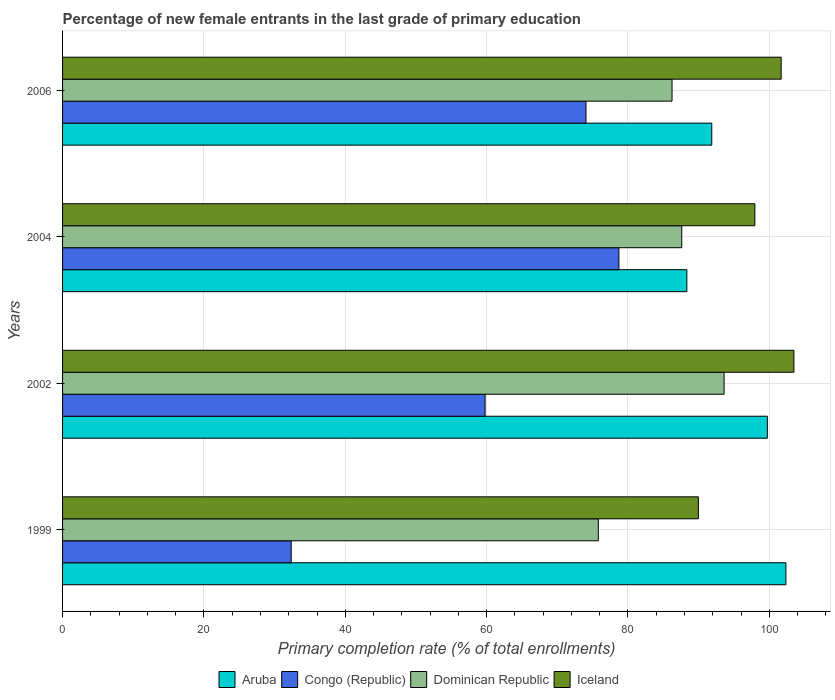Are the number of bars per tick equal to the number of legend labels?
Ensure brevity in your answer.  Yes. Are the number of bars on each tick of the Y-axis equal?
Ensure brevity in your answer.  Yes. How many bars are there on the 4th tick from the bottom?
Provide a succinct answer. 4. What is the label of the 3rd group of bars from the top?
Make the answer very short. 2002. What is the percentage of new female entrants in Congo (Republic) in 1999?
Ensure brevity in your answer.  32.35. Across all years, what is the maximum percentage of new female entrants in Dominican Republic?
Your answer should be very brief. 93.6. Across all years, what is the minimum percentage of new female entrants in Congo (Republic)?
Provide a short and direct response. 32.35. In which year was the percentage of new female entrants in Congo (Republic) maximum?
Offer a terse response. 2004. What is the total percentage of new female entrants in Aruba in the graph?
Give a very brief answer. 382.24. What is the difference between the percentage of new female entrants in Dominican Republic in 1999 and that in 2006?
Make the answer very short. -10.43. What is the difference between the percentage of new female entrants in Congo (Republic) in 2006 and the percentage of new female entrants in Iceland in 2002?
Offer a terse response. -29.42. What is the average percentage of new female entrants in Dominican Republic per year?
Provide a short and direct response. 85.81. In the year 2002, what is the difference between the percentage of new female entrants in Iceland and percentage of new female entrants in Congo (Republic)?
Keep it short and to the point. 43.7. What is the ratio of the percentage of new female entrants in Aruba in 2004 to that in 2006?
Give a very brief answer. 0.96. Is the percentage of new female entrants in Congo (Republic) in 2004 less than that in 2006?
Your answer should be very brief. No. What is the difference between the highest and the second highest percentage of new female entrants in Iceland?
Give a very brief answer. 1.8. What is the difference between the highest and the lowest percentage of new female entrants in Iceland?
Your response must be concise. 13.52. Is it the case that in every year, the sum of the percentage of new female entrants in Aruba and percentage of new female entrants in Congo (Republic) is greater than the sum of percentage of new female entrants in Dominican Republic and percentage of new female entrants in Iceland?
Your answer should be compact. No. What does the 1st bar from the bottom in 2004 represents?
Your answer should be compact. Aruba. Is it the case that in every year, the sum of the percentage of new female entrants in Congo (Republic) and percentage of new female entrants in Iceland is greater than the percentage of new female entrants in Dominican Republic?
Offer a terse response. Yes. How many years are there in the graph?
Your answer should be compact. 4. What is the difference between two consecutive major ticks on the X-axis?
Keep it short and to the point. 20. What is the title of the graph?
Provide a succinct answer. Percentage of new female entrants in the last grade of primary education. What is the label or title of the X-axis?
Provide a succinct answer. Primary completion rate (% of total enrollments). What is the label or title of the Y-axis?
Provide a succinct answer. Years. What is the Primary completion rate (% of total enrollments) in Aruba in 1999?
Offer a terse response. 102.34. What is the Primary completion rate (% of total enrollments) in Congo (Republic) in 1999?
Give a very brief answer. 32.35. What is the Primary completion rate (% of total enrollments) in Dominican Republic in 1999?
Provide a succinct answer. 75.8. What is the Primary completion rate (% of total enrollments) of Iceland in 1999?
Your answer should be very brief. 89.96. What is the Primary completion rate (% of total enrollments) in Aruba in 2002?
Make the answer very short. 99.72. What is the Primary completion rate (% of total enrollments) in Congo (Republic) in 2002?
Your answer should be compact. 59.78. What is the Primary completion rate (% of total enrollments) in Dominican Republic in 2002?
Provide a short and direct response. 93.6. What is the Primary completion rate (% of total enrollments) in Iceland in 2002?
Provide a short and direct response. 103.48. What is the Primary completion rate (% of total enrollments) of Aruba in 2004?
Make the answer very short. 88.33. What is the Primary completion rate (% of total enrollments) in Congo (Republic) in 2004?
Give a very brief answer. 78.72. What is the Primary completion rate (% of total enrollments) in Dominican Republic in 2004?
Ensure brevity in your answer.  87.61. What is the Primary completion rate (% of total enrollments) of Iceland in 2004?
Give a very brief answer. 97.95. What is the Primary completion rate (% of total enrollments) of Aruba in 2006?
Your answer should be compact. 91.85. What is the Primary completion rate (% of total enrollments) in Congo (Republic) in 2006?
Keep it short and to the point. 74.06. What is the Primary completion rate (% of total enrollments) in Dominican Republic in 2006?
Your answer should be compact. 86.23. What is the Primary completion rate (% of total enrollments) of Iceland in 2006?
Ensure brevity in your answer.  101.67. Across all years, what is the maximum Primary completion rate (% of total enrollments) in Aruba?
Offer a very short reply. 102.34. Across all years, what is the maximum Primary completion rate (% of total enrollments) of Congo (Republic)?
Your answer should be very brief. 78.72. Across all years, what is the maximum Primary completion rate (% of total enrollments) in Dominican Republic?
Keep it short and to the point. 93.6. Across all years, what is the maximum Primary completion rate (% of total enrollments) in Iceland?
Ensure brevity in your answer.  103.48. Across all years, what is the minimum Primary completion rate (% of total enrollments) of Aruba?
Provide a succinct answer. 88.33. Across all years, what is the minimum Primary completion rate (% of total enrollments) in Congo (Republic)?
Keep it short and to the point. 32.35. Across all years, what is the minimum Primary completion rate (% of total enrollments) in Dominican Republic?
Provide a succinct answer. 75.8. Across all years, what is the minimum Primary completion rate (% of total enrollments) in Iceland?
Ensure brevity in your answer.  89.96. What is the total Primary completion rate (% of total enrollments) of Aruba in the graph?
Keep it short and to the point. 382.24. What is the total Primary completion rate (% of total enrollments) in Congo (Republic) in the graph?
Offer a very short reply. 244.9. What is the total Primary completion rate (% of total enrollments) in Dominican Republic in the graph?
Offer a very short reply. 343.24. What is the total Primary completion rate (% of total enrollments) of Iceland in the graph?
Offer a very short reply. 393.06. What is the difference between the Primary completion rate (% of total enrollments) of Aruba in 1999 and that in 2002?
Keep it short and to the point. 2.62. What is the difference between the Primary completion rate (% of total enrollments) in Congo (Republic) in 1999 and that in 2002?
Offer a very short reply. -27.43. What is the difference between the Primary completion rate (% of total enrollments) in Dominican Republic in 1999 and that in 2002?
Provide a succinct answer. -17.79. What is the difference between the Primary completion rate (% of total enrollments) of Iceland in 1999 and that in 2002?
Your answer should be very brief. -13.52. What is the difference between the Primary completion rate (% of total enrollments) of Aruba in 1999 and that in 2004?
Give a very brief answer. 14.01. What is the difference between the Primary completion rate (% of total enrollments) in Congo (Republic) in 1999 and that in 2004?
Give a very brief answer. -46.37. What is the difference between the Primary completion rate (% of total enrollments) of Dominican Republic in 1999 and that in 2004?
Offer a very short reply. -11.81. What is the difference between the Primary completion rate (% of total enrollments) in Iceland in 1999 and that in 2004?
Offer a terse response. -7.99. What is the difference between the Primary completion rate (% of total enrollments) in Aruba in 1999 and that in 2006?
Offer a terse response. 10.49. What is the difference between the Primary completion rate (% of total enrollments) in Congo (Republic) in 1999 and that in 2006?
Your answer should be very brief. -41.71. What is the difference between the Primary completion rate (% of total enrollments) of Dominican Republic in 1999 and that in 2006?
Ensure brevity in your answer.  -10.43. What is the difference between the Primary completion rate (% of total enrollments) of Iceland in 1999 and that in 2006?
Keep it short and to the point. -11.72. What is the difference between the Primary completion rate (% of total enrollments) in Aruba in 2002 and that in 2004?
Your answer should be compact. 11.39. What is the difference between the Primary completion rate (% of total enrollments) in Congo (Republic) in 2002 and that in 2004?
Your answer should be compact. -18.94. What is the difference between the Primary completion rate (% of total enrollments) of Dominican Republic in 2002 and that in 2004?
Offer a very short reply. 5.99. What is the difference between the Primary completion rate (% of total enrollments) in Iceland in 2002 and that in 2004?
Provide a succinct answer. 5.53. What is the difference between the Primary completion rate (% of total enrollments) of Aruba in 2002 and that in 2006?
Offer a very short reply. 7.87. What is the difference between the Primary completion rate (% of total enrollments) in Congo (Republic) in 2002 and that in 2006?
Keep it short and to the point. -14.28. What is the difference between the Primary completion rate (% of total enrollments) of Dominican Republic in 2002 and that in 2006?
Provide a succinct answer. 7.36. What is the difference between the Primary completion rate (% of total enrollments) of Iceland in 2002 and that in 2006?
Give a very brief answer. 1.8. What is the difference between the Primary completion rate (% of total enrollments) in Aruba in 2004 and that in 2006?
Your answer should be very brief. -3.53. What is the difference between the Primary completion rate (% of total enrollments) in Congo (Republic) in 2004 and that in 2006?
Provide a short and direct response. 4.66. What is the difference between the Primary completion rate (% of total enrollments) in Dominican Republic in 2004 and that in 2006?
Keep it short and to the point. 1.38. What is the difference between the Primary completion rate (% of total enrollments) in Iceland in 2004 and that in 2006?
Provide a short and direct response. -3.72. What is the difference between the Primary completion rate (% of total enrollments) in Aruba in 1999 and the Primary completion rate (% of total enrollments) in Congo (Republic) in 2002?
Give a very brief answer. 42.56. What is the difference between the Primary completion rate (% of total enrollments) in Aruba in 1999 and the Primary completion rate (% of total enrollments) in Dominican Republic in 2002?
Give a very brief answer. 8.74. What is the difference between the Primary completion rate (% of total enrollments) in Aruba in 1999 and the Primary completion rate (% of total enrollments) in Iceland in 2002?
Give a very brief answer. -1.14. What is the difference between the Primary completion rate (% of total enrollments) in Congo (Republic) in 1999 and the Primary completion rate (% of total enrollments) in Dominican Republic in 2002?
Your response must be concise. -61.25. What is the difference between the Primary completion rate (% of total enrollments) of Congo (Republic) in 1999 and the Primary completion rate (% of total enrollments) of Iceland in 2002?
Provide a short and direct response. -71.13. What is the difference between the Primary completion rate (% of total enrollments) of Dominican Republic in 1999 and the Primary completion rate (% of total enrollments) of Iceland in 2002?
Your response must be concise. -27.68. What is the difference between the Primary completion rate (% of total enrollments) in Aruba in 1999 and the Primary completion rate (% of total enrollments) in Congo (Republic) in 2004?
Keep it short and to the point. 23.63. What is the difference between the Primary completion rate (% of total enrollments) of Aruba in 1999 and the Primary completion rate (% of total enrollments) of Dominican Republic in 2004?
Your answer should be very brief. 14.73. What is the difference between the Primary completion rate (% of total enrollments) in Aruba in 1999 and the Primary completion rate (% of total enrollments) in Iceland in 2004?
Your answer should be very brief. 4.39. What is the difference between the Primary completion rate (% of total enrollments) of Congo (Republic) in 1999 and the Primary completion rate (% of total enrollments) of Dominican Republic in 2004?
Your answer should be compact. -55.26. What is the difference between the Primary completion rate (% of total enrollments) in Congo (Republic) in 1999 and the Primary completion rate (% of total enrollments) in Iceland in 2004?
Provide a succinct answer. -65.6. What is the difference between the Primary completion rate (% of total enrollments) of Dominican Republic in 1999 and the Primary completion rate (% of total enrollments) of Iceland in 2004?
Ensure brevity in your answer.  -22.15. What is the difference between the Primary completion rate (% of total enrollments) of Aruba in 1999 and the Primary completion rate (% of total enrollments) of Congo (Republic) in 2006?
Your answer should be very brief. 28.28. What is the difference between the Primary completion rate (% of total enrollments) of Aruba in 1999 and the Primary completion rate (% of total enrollments) of Dominican Republic in 2006?
Your answer should be compact. 16.11. What is the difference between the Primary completion rate (% of total enrollments) in Aruba in 1999 and the Primary completion rate (% of total enrollments) in Iceland in 2006?
Offer a very short reply. 0.67. What is the difference between the Primary completion rate (% of total enrollments) in Congo (Republic) in 1999 and the Primary completion rate (% of total enrollments) in Dominican Republic in 2006?
Your answer should be very brief. -53.88. What is the difference between the Primary completion rate (% of total enrollments) of Congo (Republic) in 1999 and the Primary completion rate (% of total enrollments) of Iceland in 2006?
Offer a very short reply. -69.33. What is the difference between the Primary completion rate (% of total enrollments) in Dominican Republic in 1999 and the Primary completion rate (% of total enrollments) in Iceland in 2006?
Keep it short and to the point. -25.87. What is the difference between the Primary completion rate (% of total enrollments) in Aruba in 2002 and the Primary completion rate (% of total enrollments) in Congo (Republic) in 2004?
Offer a very short reply. 21. What is the difference between the Primary completion rate (% of total enrollments) in Aruba in 2002 and the Primary completion rate (% of total enrollments) in Dominican Republic in 2004?
Provide a short and direct response. 12.11. What is the difference between the Primary completion rate (% of total enrollments) in Aruba in 2002 and the Primary completion rate (% of total enrollments) in Iceland in 2004?
Your answer should be compact. 1.77. What is the difference between the Primary completion rate (% of total enrollments) of Congo (Republic) in 2002 and the Primary completion rate (% of total enrollments) of Dominican Republic in 2004?
Offer a very short reply. -27.83. What is the difference between the Primary completion rate (% of total enrollments) in Congo (Republic) in 2002 and the Primary completion rate (% of total enrollments) in Iceland in 2004?
Make the answer very short. -38.17. What is the difference between the Primary completion rate (% of total enrollments) in Dominican Republic in 2002 and the Primary completion rate (% of total enrollments) in Iceland in 2004?
Offer a terse response. -4.35. What is the difference between the Primary completion rate (% of total enrollments) of Aruba in 2002 and the Primary completion rate (% of total enrollments) of Congo (Republic) in 2006?
Provide a succinct answer. 25.66. What is the difference between the Primary completion rate (% of total enrollments) in Aruba in 2002 and the Primary completion rate (% of total enrollments) in Dominican Republic in 2006?
Make the answer very short. 13.49. What is the difference between the Primary completion rate (% of total enrollments) in Aruba in 2002 and the Primary completion rate (% of total enrollments) in Iceland in 2006?
Your answer should be compact. -1.95. What is the difference between the Primary completion rate (% of total enrollments) of Congo (Republic) in 2002 and the Primary completion rate (% of total enrollments) of Dominican Republic in 2006?
Give a very brief answer. -26.45. What is the difference between the Primary completion rate (% of total enrollments) of Congo (Republic) in 2002 and the Primary completion rate (% of total enrollments) of Iceland in 2006?
Make the answer very short. -41.89. What is the difference between the Primary completion rate (% of total enrollments) of Dominican Republic in 2002 and the Primary completion rate (% of total enrollments) of Iceland in 2006?
Provide a short and direct response. -8.08. What is the difference between the Primary completion rate (% of total enrollments) in Aruba in 2004 and the Primary completion rate (% of total enrollments) in Congo (Republic) in 2006?
Ensure brevity in your answer.  14.27. What is the difference between the Primary completion rate (% of total enrollments) of Aruba in 2004 and the Primary completion rate (% of total enrollments) of Dominican Republic in 2006?
Provide a succinct answer. 2.1. What is the difference between the Primary completion rate (% of total enrollments) in Aruba in 2004 and the Primary completion rate (% of total enrollments) in Iceland in 2006?
Your response must be concise. -13.35. What is the difference between the Primary completion rate (% of total enrollments) in Congo (Republic) in 2004 and the Primary completion rate (% of total enrollments) in Dominican Republic in 2006?
Ensure brevity in your answer.  -7.52. What is the difference between the Primary completion rate (% of total enrollments) of Congo (Republic) in 2004 and the Primary completion rate (% of total enrollments) of Iceland in 2006?
Your answer should be very brief. -22.96. What is the difference between the Primary completion rate (% of total enrollments) in Dominican Republic in 2004 and the Primary completion rate (% of total enrollments) in Iceland in 2006?
Provide a short and direct response. -14.06. What is the average Primary completion rate (% of total enrollments) of Aruba per year?
Provide a succinct answer. 95.56. What is the average Primary completion rate (% of total enrollments) of Congo (Republic) per year?
Ensure brevity in your answer.  61.23. What is the average Primary completion rate (% of total enrollments) of Dominican Republic per year?
Keep it short and to the point. 85.81. What is the average Primary completion rate (% of total enrollments) of Iceland per year?
Keep it short and to the point. 98.26. In the year 1999, what is the difference between the Primary completion rate (% of total enrollments) in Aruba and Primary completion rate (% of total enrollments) in Congo (Republic)?
Your response must be concise. 69.99. In the year 1999, what is the difference between the Primary completion rate (% of total enrollments) of Aruba and Primary completion rate (% of total enrollments) of Dominican Republic?
Keep it short and to the point. 26.54. In the year 1999, what is the difference between the Primary completion rate (% of total enrollments) in Aruba and Primary completion rate (% of total enrollments) in Iceland?
Offer a very short reply. 12.38. In the year 1999, what is the difference between the Primary completion rate (% of total enrollments) of Congo (Republic) and Primary completion rate (% of total enrollments) of Dominican Republic?
Provide a short and direct response. -43.45. In the year 1999, what is the difference between the Primary completion rate (% of total enrollments) of Congo (Republic) and Primary completion rate (% of total enrollments) of Iceland?
Provide a succinct answer. -57.61. In the year 1999, what is the difference between the Primary completion rate (% of total enrollments) of Dominican Republic and Primary completion rate (% of total enrollments) of Iceland?
Offer a very short reply. -14.15. In the year 2002, what is the difference between the Primary completion rate (% of total enrollments) in Aruba and Primary completion rate (% of total enrollments) in Congo (Republic)?
Make the answer very short. 39.94. In the year 2002, what is the difference between the Primary completion rate (% of total enrollments) of Aruba and Primary completion rate (% of total enrollments) of Dominican Republic?
Provide a succinct answer. 6.12. In the year 2002, what is the difference between the Primary completion rate (% of total enrollments) in Aruba and Primary completion rate (% of total enrollments) in Iceland?
Offer a terse response. -3.76. In the year 2002, what is the difference between the Primary completion rate (% of total enrollments) of Congo (Republic) and Primary completion rate (% of total enrollments) of Dominican Republic?
Your answer should be compact. -33.82. In the year 2002, what is the difference between the Primary completion rate (% of total enrollments) of Congo (Republic) and Primary completion rate (% of total enrollments) of Iceland?
Your answer should be very brief. -43.7. In the year 2002, what is the difference between the Primary completion rate (% of total enrollments) in Dominican Republic and Primary completion rate (% of total enrollments) in Iceland?
Your answer should be very brief. -9.88. In the year 2004, what is the difference between the Primary completion rate (% of total enrollments) of Aruba and Primary completion rate (% of total enrollments) of Congo (Republic)?
Your response must be concise. 9.61. In the year 2004, what is the difference between the Primary completion rate (% of total enrollments) of Aruba and Primary completion rate (% of total enrollments) of Dominican Republic?
Keep it short and to the point. 0.72. In the year 2004, what is the difference between the Primary completion rate (% of total enrollments) of Aruba and Primary completion rate (% of total enrollments) of Iceland?
Give a very brief answer. -9.62. In the year 2004, what is the difference between the Primary completion rate (% of total enrollments) of Congo (Republic) and Primary completion rate (% of total enrollments) of Dominican Republic?
Provide a short and direct response. -8.89. In the year 2004, what is the difference between the Primary completion rate (% of total enrollments) in Congo (Republic) and Primary completion rate (% of total enrollments) in Iceland?
Provide a succinct answer. -19.24. In the year 2004, what is the difference between the Primary completion rate (% of total enrollments) of Dominican Republic and Primary completion rate (% of total enrollments) of Iceland?
Your response must be concise. -10.34. In the year 2006, what is the difference between the Primary completion rate (% of total enrollments) in Aruba and Primary completion rate (% of total enrollments) in Congo (Republic)?
Your answer should be compact. 17.8. In the year 2006, what is the difference between the Primary completion rate (% of total enrollments) in Aruba and Primary completion rate (% of total enrollments) in Dominican Republic?
Your answer should be very brief. 5.62. In the year 2006, what is the difference between the Primary completion rate (% of total enrollments) of Aruba and Primary completion rate (% of total enrollments) of Iceland?
Offer a very short reply. -9.82. In the year 2006, what is the difference between the Primary completion rate (% of total enrollments) of Congo (Republic) and Primary completion rate (% of total enrollments) of Dominican Republic?
Provide a succinct answer. -12.17. In the year 2006, what is the difference between the Primary completion rate (% of total enrollments) in Congo (Republic) and Primary completion rate (% of total enrollments) in Iceland?
Give a very brief answer. -27.62. In the year 2006, what is the difference between the Primary completion rate (% of total enrollments) of Dominican Republic and Primary completion rate (% of total enrollments) of Iceland?
Offer a very short reply. -15.44. What is the ratio of the Primary completion rate (% of total enrollments) in Aruba in 1999 to that in 2002?
Your response must be concise. 1.03. What is the ratio of the Primary completion rate (% of total enrollments) in Congo (Republic) in 1999 to that in 2002?
Ensure brevity in your answer.  0.54. What is the ratio of the Primary completion rate (% of total enrollments) of Dominican Republic in 1999 to that in 2002?
Keep it short and to the point. 0.81. What is the ratio of the Primary completion rate (% of total enrollments) of Iceland in 1999 to that in 2002?
Provide a short and direct response. 0.87. What is the ratio of the Primary completion rate (% of total enrollments) of Aruba in 1999 to that in 2004?
Give a very brief answer. 1.16. What is the ratio of the Primary completion rate (% of total enrollments) in Congo (Republic) in 1999 to that in 2004?
Make the answer very short. 0.41. What is the ratio of the Primary completion rate (% of total enrollments) of Dominican Republic in 1999 to that in 2004?
Keep it short and to the point. 0.87. What is the ratio of the Primary completion rate (% of total enrollments) of Iceland in 1999 to that in 2004?
Keep it short and to the point. 0.92. What is the ratio of the Primary completion rate (% of total enrollments) in Aruba in 1999 to that in 2006?
Your answer should be compact. 1.11. What is the ratio of the Primary completion rate (% of total enrollments) of Congo (Republic) in 1999 to that in 2006?
Make the answer very short. 0.44. What is the ratio of the Primary completion rate (% of total enrollments) of Dominican Republic in 1999 to that in 2006?
Your response must be concise. 0.88. What is the ratio of the Primary completion rate (% of total enrollments) in Iceland in 1999 to that in 2006?
Provide a short and direct response. 0.88. What is the ratio of the Primary completion rate (% of total enrollments) in Aruba in 2002 to that in 2004?
Offer a terse response. 1.13. What is the ratio of the Primary completion rate (% of total enrollments) of Congo (Republic) in 2002 to that in 2004?
Provide a succinct answer. 0.76. What is the ratio of the Primary completion rate (% of total enrollments) of Dominican Republic in 2002 to that in 2004?
Keep it short and to the point. 1.07. What is the ratio of the Primary completion rate (% of total enrollments) in Iceland in 2002 to that in 2004?
Provide a short and direct response. 1.06. What is the ratio of the Primary completion rate (% of total enrollments) in Aruba in 2002 to that in 2006?
Keep it short and to the point. 1.09. What is the ratio of the Primary completion rate (% of total enrollments) in Congo (Republic) in 2002 to that in 2006?
Keep it short and to the point. 0.81. What is the ratio of the Primary completion rate (% of total enrollments) in Dominican Republic in 2002 to that in 2006?
Your answer should be very brief. 1.09. What is the ratio of the Primary completion rate (% of total enrollments) of Iceland in 2002 to that in 2006?
Offer a terse response. 1.02. What is the ratio of the Primary completion rate (% of total enrollments) in Aruba in 2004 to that in 2006?
Provide a succinct answer. 0.96. What is the ratio of the Primary completion rate (% of total enrollments) in Congo (Republic) in 2004 to that in 2006?
Offer a terse response. 1.06. What is the ratio of the Primary completion rate (% of total enrollments) of Iceland in 2004 to that in 2006?
Your response must be concise. 0.96. What is the difference between the highest and the second highest Primary completion rate (% of total enrollments) of Aruba?
Keep it short and to the point. 2.62. What is the difference between the highest and the second highest Primary completion rate (% of total enrollments) of Congo (Republic)?
Make the answer very short. 4.66. What is the difference between the highest and the second highest Primary completion rate (% of total enrollments) of Dominican Republic?
Offer a terse response. 5.99. What is the difference between the highest and the second highest Primary completion rate (% of total enrollments) of Iceland?
Keep it short and to the point. 1.8. What is the difference between the highest and the lowest Primary completion rate (% of total enrollments) of Aruba?
Keep it short and to the point. 14.01. What is the difference between the highest and the lowest Primary completion rate (% of total enrollments) of Congo (Republic)?
Provide a succinct answer. 46.37. What is the difference between the highest and the lowest Primary completion rate (% of total enrollments) in Dominican Republic?
Offer a very short reply. 17.79. What is the difference between the highest and the lowest Primary completion rate (% of total enrollments) in Iceland?
Your response must be concise. 13.52. 